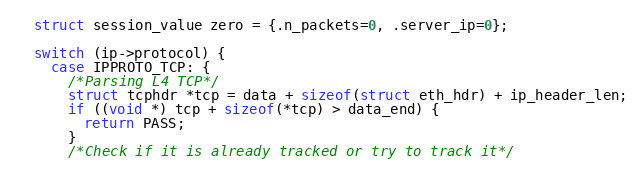<code> <loc_0><loc_0><loc_500><loc_500><_C_>  struct session_value zero = {.n_packets=0, .server_ip=0};

  switch (ip->protocol) {
    case IPPROTO_TCP: {
      /*Parsing L4 TCP*/
      struct tcphdr *tcp = data + sizeof(struct eth_hdr) + ip_header_len;
      if ((void *) tcp + sizeof(*tcp) > data_end) {
        return PASS;
      }
      /*Check if it is already tracked or try to track it*/</code> 